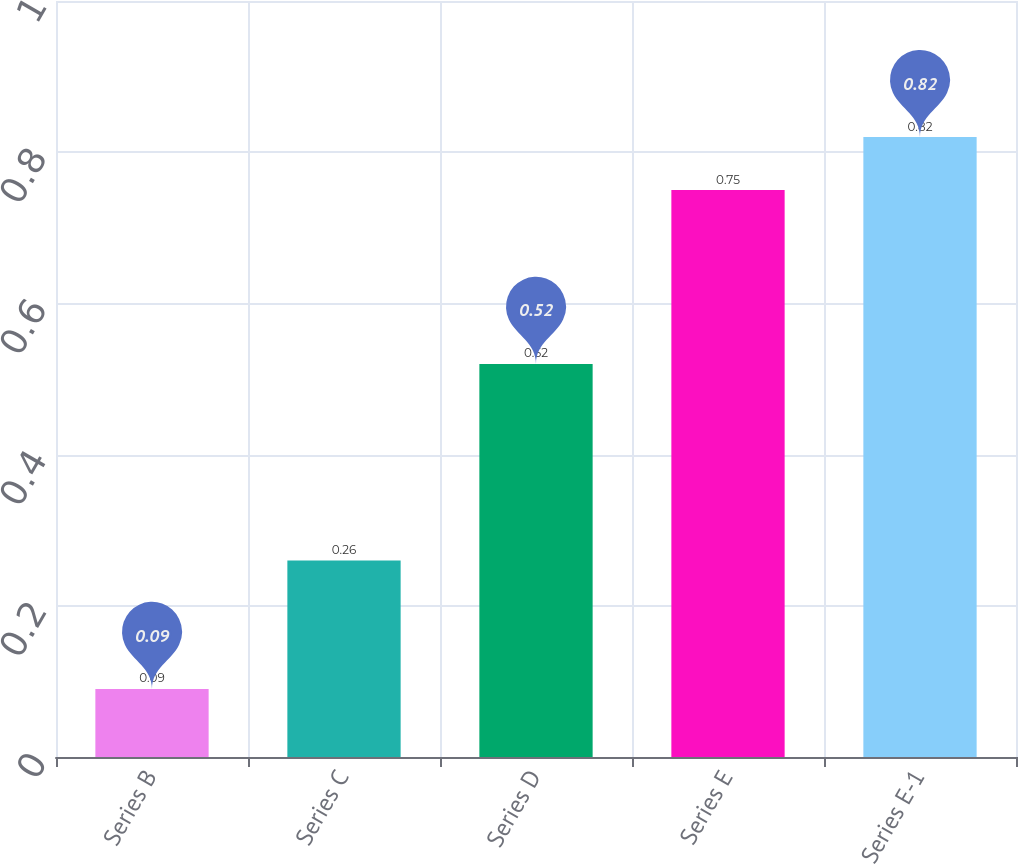Convert chart. <chart><loc_0><loc_0><loc_500><loc_500><bar_chart><fcel>Series B<fcel>Series C<fcel>Series D<fcel>Series E<fcel>Series E-1<nl><fcel>0.09<fcel>0.26<fcel>0.52<fcel>0.75<fcel>0.82<nl></chart> 